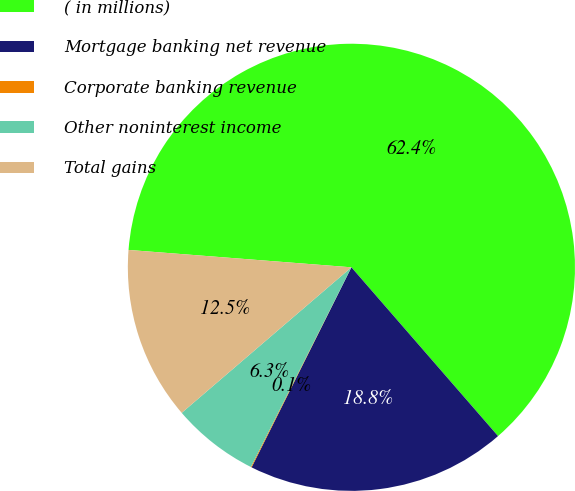<chart> <loc_0><loc_0><loc_500><loc_500><pie_chart><fcel>( in millions)<fcel>Mortgage banking net revenue<fcel>Corporate banking revenue<fcel>Other noninterest income<fcel>Total gains<nl><fcel>62.37%<fcel>18.75%<fcel>0.06%<fcel>6.29%<fcel>12.52%<nl></chart> 